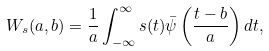<formula> <loc_0><loc_0><loc_500><loc_500>W _ { s } ( a , b ) = \frac { 1 } { a } \int _ { - \infty } ^ { \infty } s ( t ) \bar { \psi } \left ( \frac { t - b } { a } \right ) d t ,</formula> 